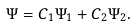Convert formula to latex. <formula><loc_0><loc_0><loc_500><loc_500>\Psi = C _ { 1 } \Psi _ { 1 } + C _ { 2 } \Psi _ { 2 } .</formula> 